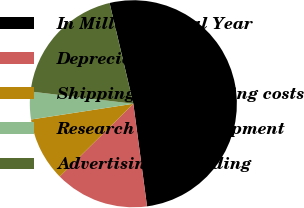Convert chart. <chart><loc_0><loc_0><loc_500><loc_500><pie_chart><fcel>In Millions Fiscal Year<fcel>Depreciation<fcel>Shipping and handling costs<fcel>Research and development<fcel>Advertising (including<nl><fcel>51.57%<fcel>14.7%<fcel>9.98%<fcel>4.32%<fcel>19.43%<nl></chart> 